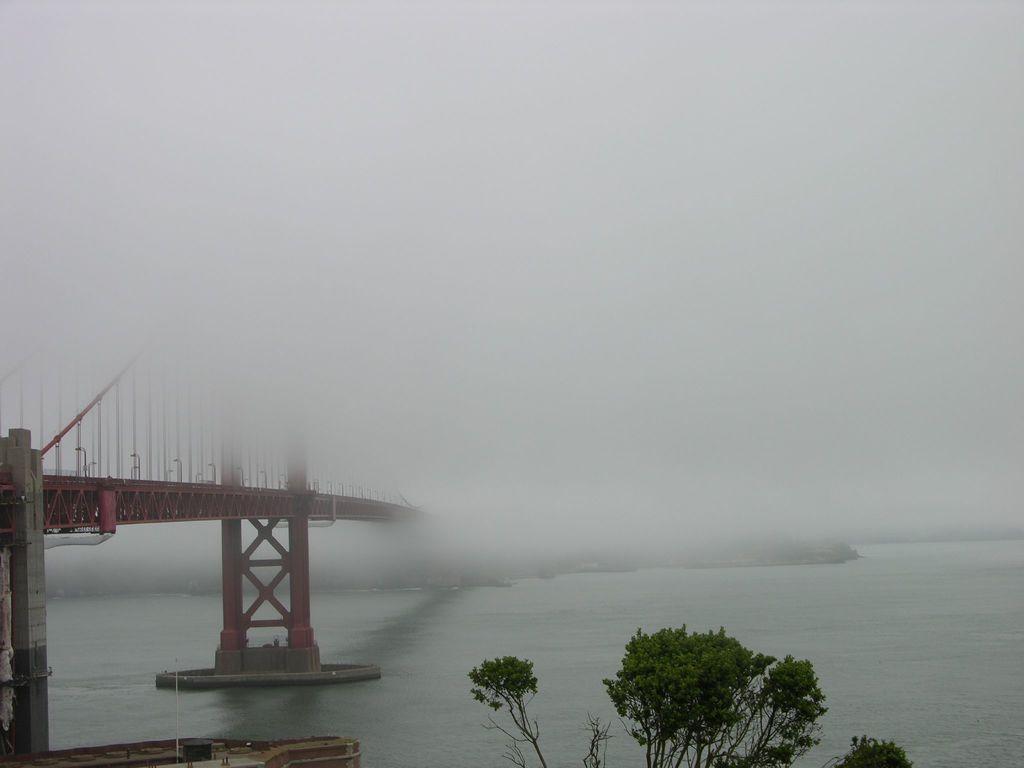Could you give a brief overview of what you see in this image? In this picture we can see the water. At the top we can see the fog. On the left there is a bridge. At the bottom we can see the trees. In the bottom left corner we can see the pole, fencing and other objects. 